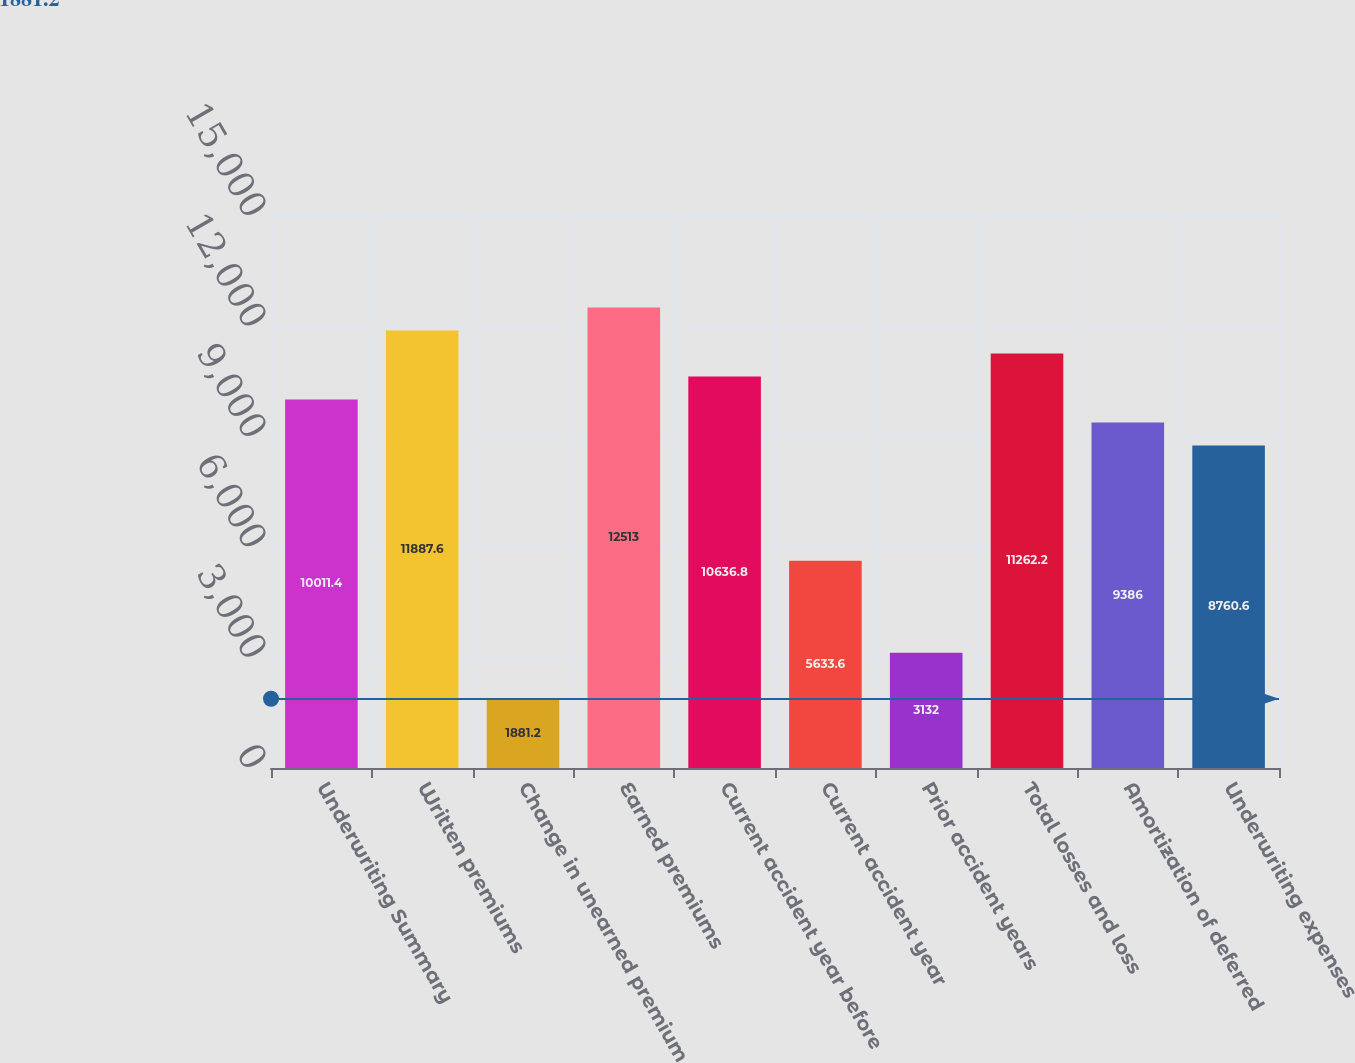Convert chart. <chart><loc_0><loc_0><loc_500><loc_500><bar_chart><fcel>Underwriting Summary<fcel>Written premiums<fcel>Change in unearned premium<fcel>Earned premiums<fcel>Current accident year before<fcel>Current accident year<fcel>Prior accident years<fcel>Total losses and loss<fcel>Amortization of deferred<fcel>Underwriting expenses<nl><fcel>10011.4<fcel>11887.6<fcel>1881.2<fcel>12513<fcel>10636.8<fcel>5633.6<fcel>3132<fcel>11262.2<fcel>9386<fcel>8760.6<nl></chart> 